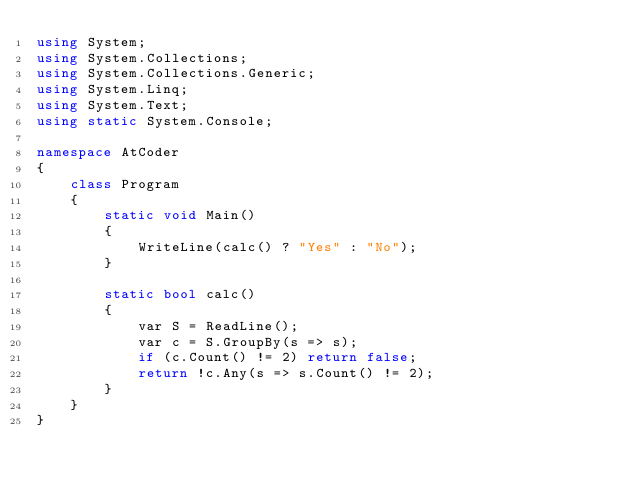<code> <loc_0><loc_0><loc_500><loc_500><_C#_>using System;
using System.Collections;
using System.Collections.Generic;
using System.Linq;
using System.Text;
using static System.Console;

namespace AtCoder
{
    class Program
    {
        static void Main()
        {
            WriteLine(calc() ? "Yes" : "No");
        }

        static bool calc()
        {
            var S = ReadLine();
            var c = S.GroupBy(s => s);
            if (c.Count() != 2) return false;
            return !c.Any(s => s.Count() != 2);
        }
    }
}
</code> 